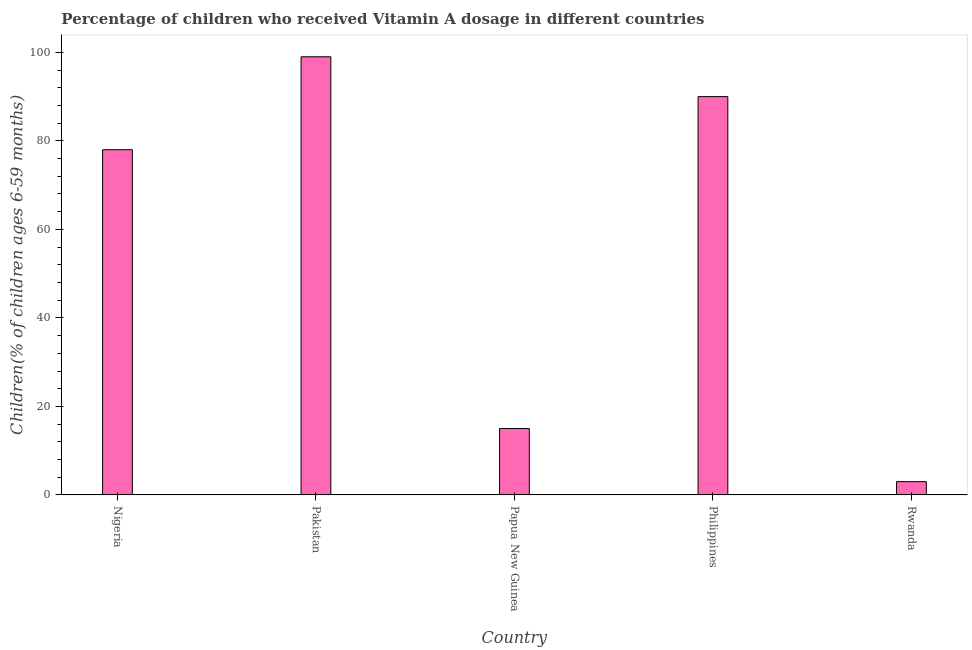Does the graph contain any zero values?
Your answer should be very brief. No. What is the title of the graph?
Ensure brevity in your answer.  Percentage of children who received Vitamin A dosage in different countries. What is the label or title of the X-axis?
Your answer should be compact. Country. What is the label or title of the Y-axis?
Offer a terse response. Children(% of children ages 6-59 months). What is the vitamin a supplementation coverage rate in Rwanda?
Make the answer very short. 3. Across all countries, what is the minimum vitamin a supplementation coverage rate?
Provide a succinct answer. 3. In which country was the vitamin a supplementation coverage rate maximum?
Your answer should be very brief. Pakistan. In which country was the vitamin a supplementation coverage rate minimum?
Provide a short and direct response. Rwanda. What is the sum of the vitamin a supplementation coverage rate?
Keep it short and to the point. 285. What is the average vitamin a supplementation coverage rate per country?
Give a very brief answer. 57. What is the median vitamin a supplementation coverage rate?
Your response must be concise. 78. Is the vitamin a supplementation coverage rate in Philippines less than that in Rwanda?
Ensure brevity in your answer.  No. Is the difference between the vitamin a supplementation coverage rate in Pakistan and Rwanda greater than the difference between any two countries?
Ensure brevity in your answer.  Yes. What is the difference between the highest and the lowest vitamin a supplementation coverage rate?
Make the answer very short. 96. In how many countries, is the vitamin a supplementation coverage rate greater than the average vitamin a supplementation coverage rate taken over all countries?
Ensure brevity in your answer.  3. What is the difference between two consecutive major ticks on the Y-axis?
Offer a very short reply. 20. What is the Children(% of children ages 6-59 months) in Papua New Guinea?
Provide a succinct answer. 15. What is the difference between the Children(% of children ages 6-59 months) in Nigeria and Rwanda?
Offer a very short reply. 75. What is the difference between the Children(% of children ages 6-59 months) in Pakistan and Papua New Guinea?
Give a very brief answer. 84. What is the difference between the Children(% of children ages 6-59 months) in Pakistan and Philippines?
Ensure brevity in your answer.  9. What is the difference between the Children(% of children ages 6-59 months) in Pakistan and Rwanda?
Make the answer very short. 96. What is the difference between the Children(% of children ages 6-59 months) in Papua New Guinea and Philippines?
Offer a terse response. -75. What is the difference between the Children(% of children ages 6-59 months) in Papua New Guinea and Rwanda?
Ensure brevity in your answer.  12. What is the ratio of the Children(% of children ages 6-59 months) in Nigeria to that in Pakistan?
Give a very brief answer. 0.79. What is the ratio of the Children(% of children ages 6-59 months) in Nigeria to that in Papua New Guinea?
Offer a terse response. 5.2. What is the ratio of the Children(% of children ages 6-59 months) in Nigeria to that in Philippines?
Offer a very short reply. 0.87. What is the ratio of the Children(% of children ages 6-59 months) in Nigeria to that in Rwanda?
Your answer should be compact. 26. What is the ratio of the Children(% of children ages 6-59 months) in Pakistan to that in Papua New Guinea?
Offer a very short reply. 6.6. What is the ratio of the Children(% of children ages 6-59 months) in Pakistan to that in Philippines?
Give a very brief answer. 1.1. What is the ratio of the Children(% of children ages 6-59 months) in Papua New Guinea to that in Philippines?
Keep it short and to the point. 0.17. What is the ratio of the Children(% of children ages 6-59 months) in Papua New Guinea to that in Rwanda?
Your answer should be very brief. 5. 